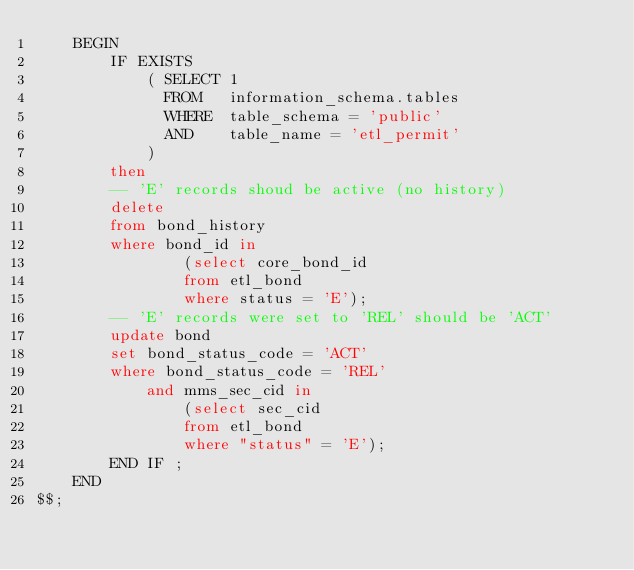<code> <loc_0><loc_0><loc_500><loc_500><_SQL_>    BEGIN
        IF EXISTS
            ( SELECT 1
              FROM   information_schema.tables
              WHERE  table_schema = 'public'
              AND    table_name = 'etl_permit'
            )
        then
        -- 'E' records shoud be active (no history)
        delete
        from bond_history
        where bond_id in
                (select core_bond_id
                from etl_bond
                where status = 'E');
        -- 'E' records were set to 'REL' should be 'ACT'
        update bond
        set bond_status_code = 'ACT'
        where bond_status_code = 'REL'
            and mms_sec_cid in
                (select sec_cid
                from etl_bond
                where "status" = 'E');
        END IF ;
    END
$$;</code> 